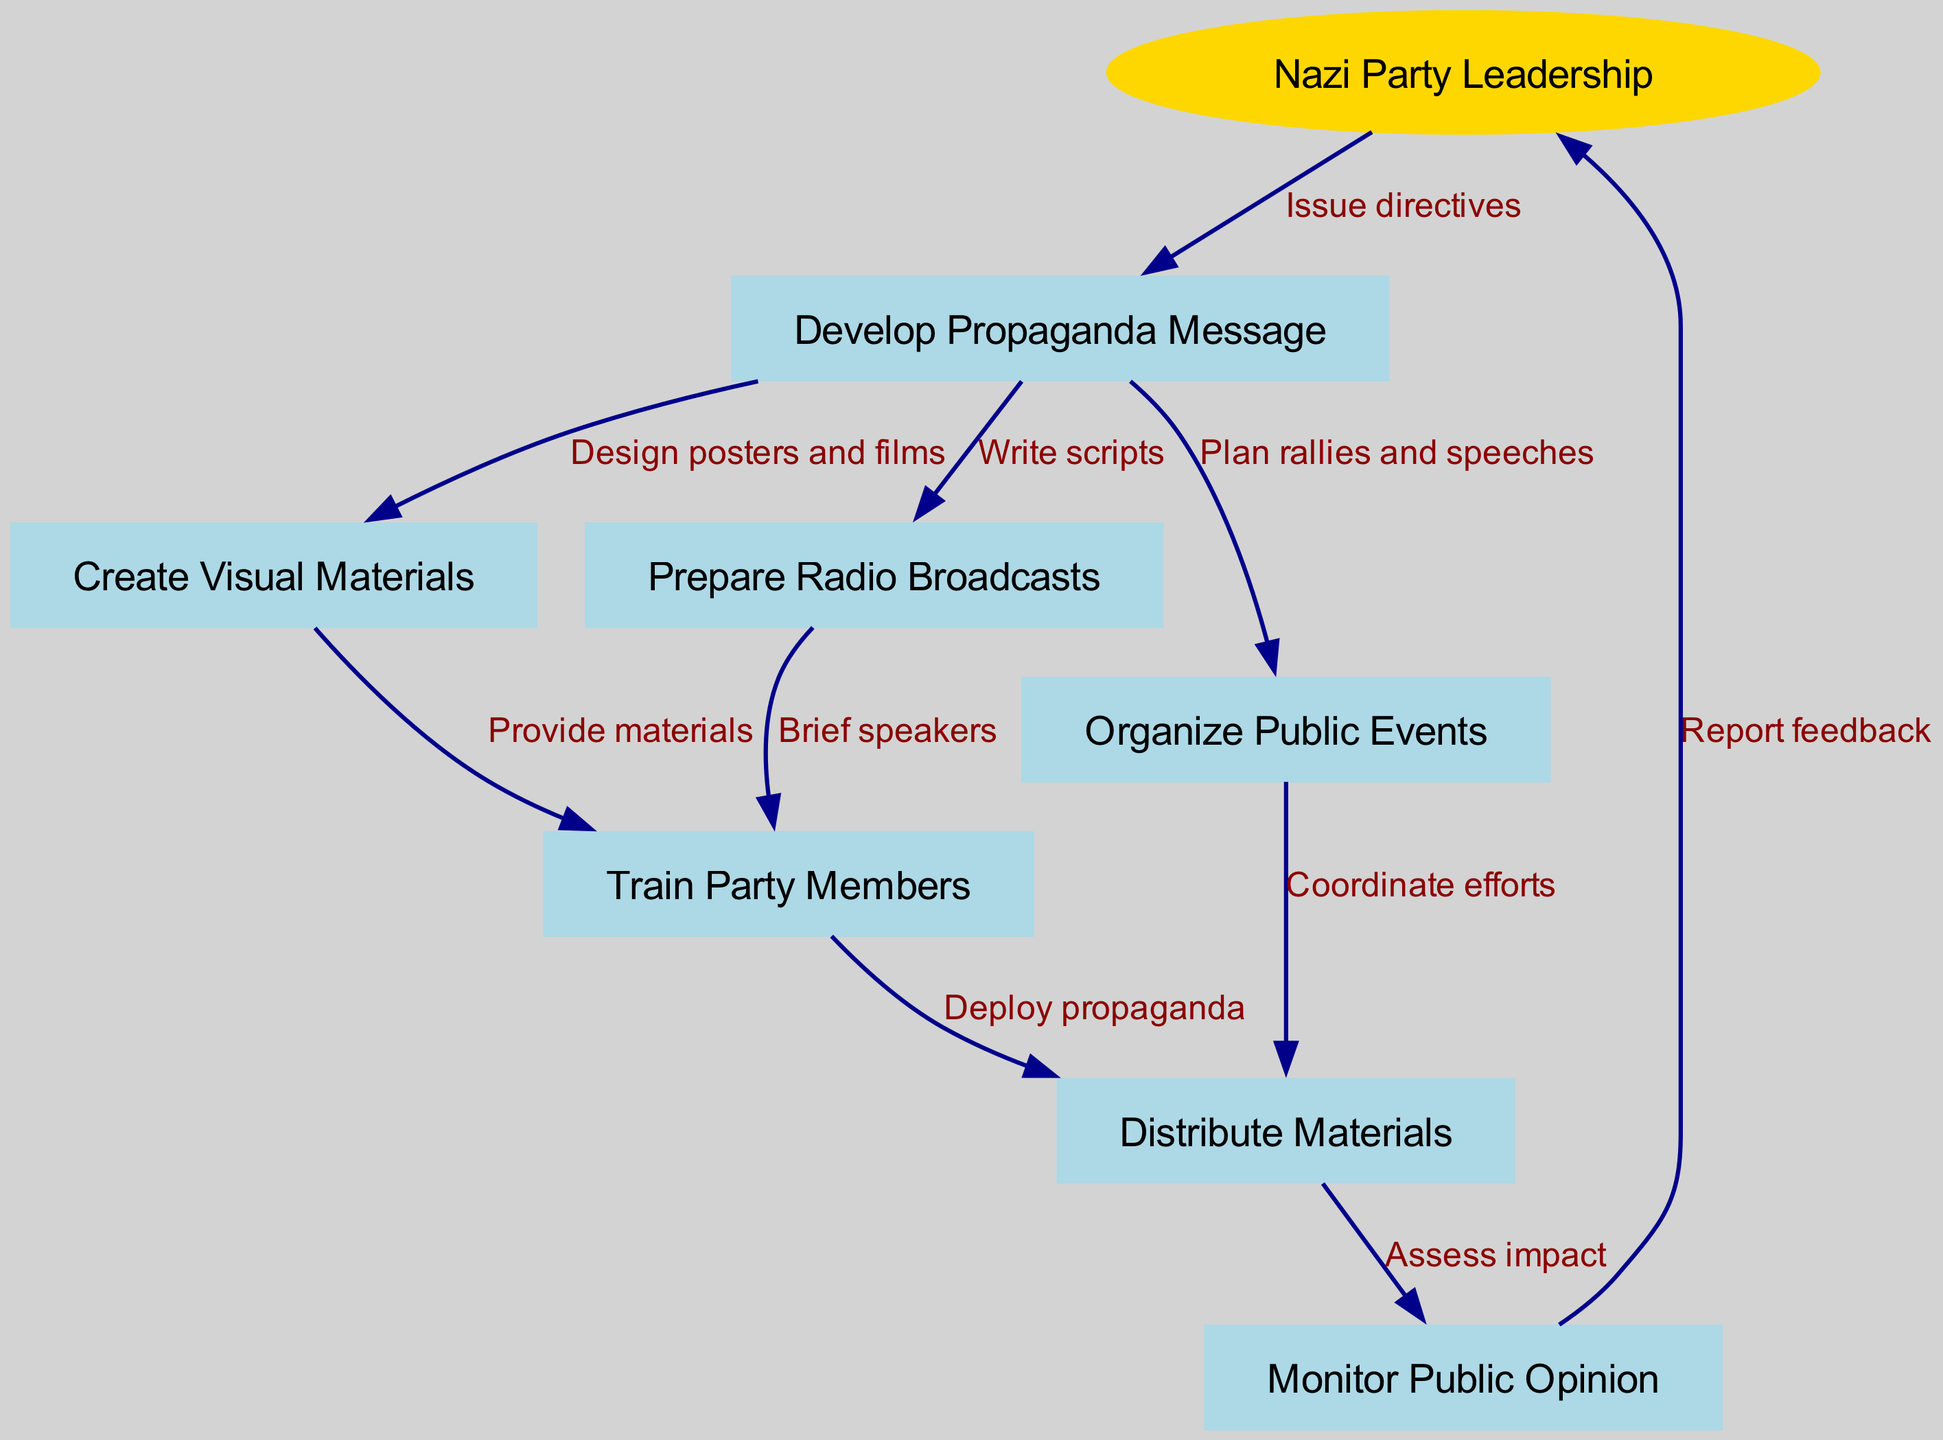What is the starting point of the flowchart? The starting point of the flowchart is indicated as "Nazi Party Leadership," which is the first node listed in the data and is drawn as an oval shape in the diagram.
Answer: Nazi Party Leadership How many nodes are in the diagram? The diagram contains a total of 8 nodes: 1 starting node (Nazi Party Leadership) and 7 other nodes. This can be determined by counting the unique nodes listed in the data.
Answer: 8 What is the relationship between "Nazi Party Leadership" and "Develop Propaganda Message"? The relationship is described by the edge labeled "Issue directives," which shows that the Nazi Party Leadership issues directives leading to the development of the propaganda message.
Answer: Issue directives What is the next step after preparing radio broadcasts? After preparing radio broadcasts, the next step is to "Train Party Members," as indicated by the directed edge from "Prepare Radio Broadcasts" to "Train Party Members."
Answer: Train Party Members Which node comes after "Distribute Materials"? After "Distribute Materials," the flowchart indicates to "Monitor Public Opinion," as shown by the directed edge leading from "Distribute Materials" to "Monitor Public Opinion."
Answer: Monitor Public Opinion How many edges are originating from "Develop Propaganda Message"? There are three edges originating from "Develop Propaganda Message," connecting to "Create Visual Materials," "Prepare Radio Broadcasts," and "Organize Public Events." This can be verified by counting the edges listed in the data that start from this node.
Answer: 3 What labels are associated with the edge linking "Create Visual Materials" and "Train Party Members"? The label associated with the edge linking these two nodes is "Provide materials," which indicates the action taken as part of the propaganda process.
Answer: Provide materials Which two nodes are connected by the edge labeled "Assess impact"? The edge labeled "Assess impact" connects "Distribute Materials" to "Monitor Public Opinion," indicating the action of assessing the effectiveness of the distributed materials.
Answer: Distribute Materials and Monitor Public Opinion What does the "Monitor Public Opinion" node report to? The "Monitor Public Opinion" node reports feedback back to the "Nazi Party Leadership," as indicated by the edge labeled "Report feedback," which directs the flow back to the leadership.
Answer: Nazi Party Leadership 